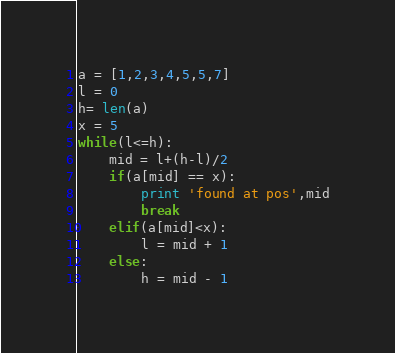Convert code to text. <code><loc_0><loc_0><loc_500><loc_500><_Python_>a = [1,2,3,4,5,5,7]
l = 0
h= len(a)
x = 5
while(l<=h):
	mid = l+(h-l)/2
	if(a[mid] == x):
		print 'found at pos',mid
		break
	elif(a[mid]<x):
		l = mid + 1
	else:
		h = mid - 1

</code> 